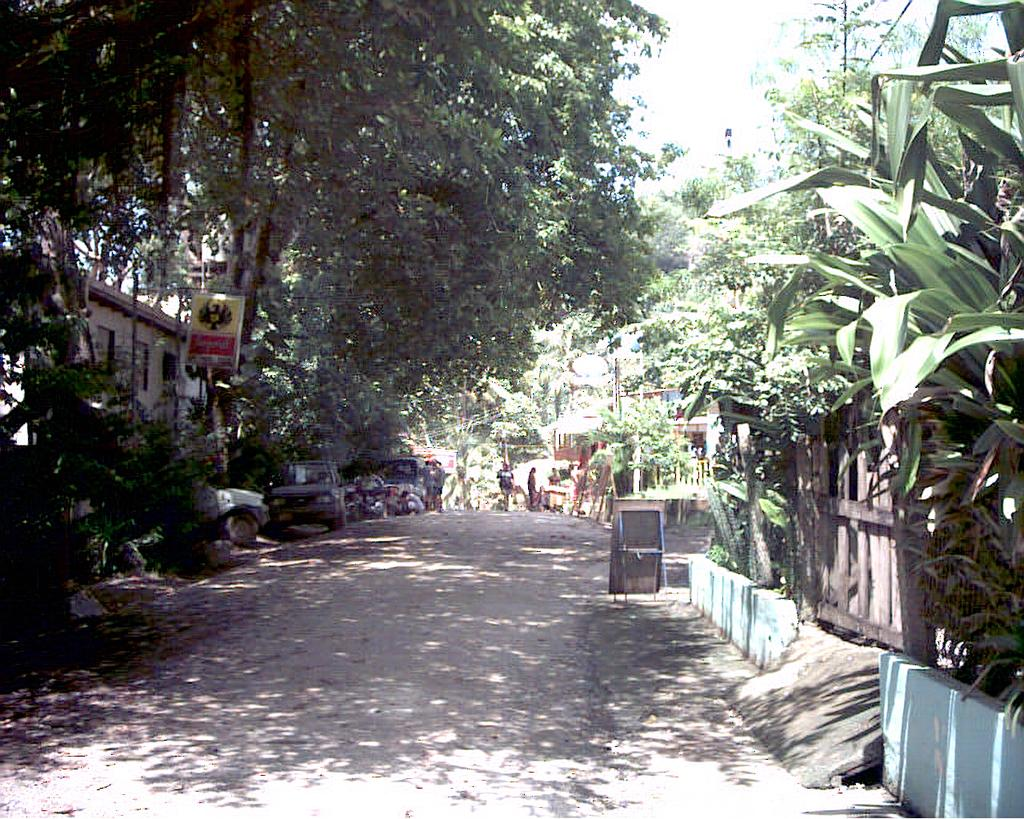What types of objects can be seen in the image? There are vehicles, a board, and a fence in the image. Are there any living beings present? Yes, there are people in the image. What can be seen in the background of the image? The sky is visible in the background of the image. What type of vegetation is present? There are trees and plants in the image. What type of structures can be seen? There are houses in the image. What is the primary mode of transportation for the vehicles? There is a road in the image, which suggests that the vehicles are on the road. Can you tell me how many toes the robin has in the image? There is no robin present in the image, so it is not possible to determine the number of toes it might have. What type of can is being used by the people in the image? There is no can visible in the image; the objects mentioned in the facts are vehicles, a board, and a fence. 